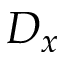Convert formula to latex. <formula><loc_0><loc_0><loc_500><loc_500>D _ { x }</formula> 